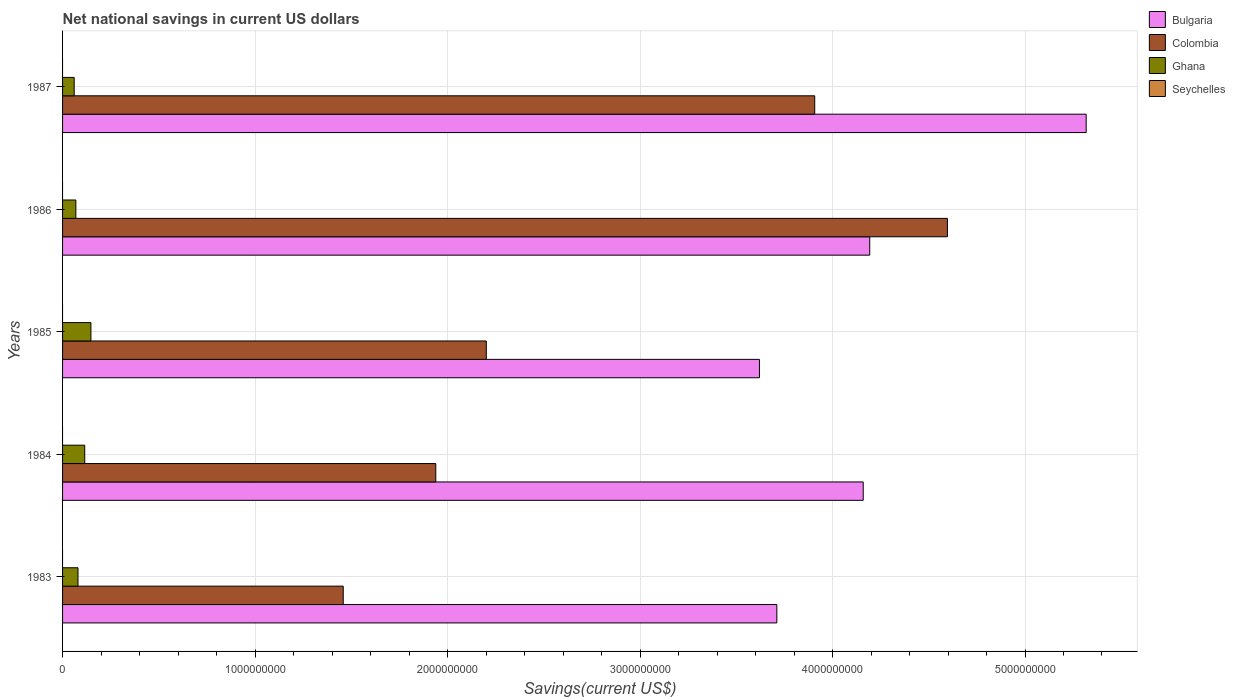How many different coloured bars are there?
Your answer should be compact. 3. How many groups of bars are there?
Offer a very short reply. 5. Are the number of bars per tick equal to the number of legend labels?
Your answer should be compact. No. Are the number of bars on each tick of the Y-axis equal?
Make the answer very short. Yes. Across all years, what is the maximum net national savings in Ghana?
Offer a very short reply. 1.47e+08. In which year was the net national savings in Colombia maximum?
Provide a short and direct response. 1986. What is the total net national savings in Bulgaria in the graph?
Offer a very short reply. 2.10e+1. What is the difference between the net national savings in Ghana in 1983 and that in 1984?
Your response must be concise. -3.50e+07. What is the difference between the net national savings in Ghana in 1987 and the net national savings in Seychelles in 1984?
Your response must be concise. 6.04e+07. What is the average net national savings in Colombia per year?
Offer a very short reply. 2.82e+09. In the year 1985, what is the difference between the net national savings in Bulgaria and net national savings in Colombia?
Make the answer very short. 1.42e+09. What is the ratio of the net national savings in Colombia in 1983 to that in 1987?
Offer a very short reply. 0.37. Is the net national savings in Bulgaria in 1983 less than that in 1984?
Offer a very short reply. Yes. What is the difference between the highest and the second highest net national savings in Ghana?
Keep it short and to the point. 3.21e+07. What is the difference between the highest and the lowest net national savings in Colombia?
Provide a short and direct response. 3.14e+09. Is the sum of the net national savings in Ghana in 1983 and 1985 greater than the maximum net national savings in Bulgaria across all years?
Ensure brevity in your answer.  No. Is it the case that in every year, the sum of the net national savings in Seychelles and net national savings in Colombia is greater than the sum of net national savings in Ghana and net national savings in Bulgaria?
Give a very brief answer. No. How many years are there in the graph?
Ensure brevity in your answer.  5. What is the difference between two consecutive major ticks on the X-axis?
Ensure brevity in your answer.  1.00e+09. Are the values on the major ticks of X-axis written in scientific E-notation?
Ensure brevity in your answer.  No. Does the graph contain grids?
Your answer should be compact. Yes. How many legend labels are there?
Keep it short and to the point. 4. What is the title of the graph?
Keep it short and to the point. Net national savings in current US dollars. What is the label or title of the X-axis?
Your response must be concise. Savings(current US$). What is the label or title of the Y-axis?
Your response must be concise. Years. What is the Savings(current US$) of Bulgaria in 1983?
Provide a succinct answer. 3.71e+09. What is the Savings(current US$) in Colombia in 1983?
Your response must be concise. 1.46e+09. What is the Savings(current US$) in Ghana in 1983?
Provide a succinct answer. 8.02e+07. What is the Savings(current US$) in Bulgaria in 1984?
Give a very brief answer. 4.16e+09. What is the Savings(current US$) of Colombia in 1984?
Your response must be concise. 1.94e+09. What is the Savings(current US$) of Ghana in 1984?
Your answer should be compact. 1.15e+08. What is the Savings(current US$) of Seychelles in 1984?
Ensure brevity in your answer.  0. What is the Savings(current US$) of Bulgaria in 1985?
Keep it short and to the point. 3.62e+09. What is the Savings(current US$) of Colombia in 1985?
Your response must be concise. 2.20e+09. What is the Savings(current US$) in Ghana in 1985?
Your answer should be compact. 1.47e+08. What is the Savings(current US$) of Bulgaria in 1986?
Make the answer very short. 4.19e+09. What is the Savings(current US$) of Colombia in 1986?
Provide a succinct answer. 4.60e+09. What is the Savings(current US$) in Ghana in 1986?
Give a very brief answer. 6.91e+07. What is the Savings(current US$) in Bulgaria in 1987?
Your answer should be compact. 5.32e+09. What is the Savings(current US$) in Colombia in 1987?
Offer a very short reply. 3.91e+09. What is the Savings(current US$) of Ghana in 1987?
Offer a terse response. 6.04e+07. Across all years, what is the maximum Savings(current US$) of Bulgaria?
Keep it short and to the point. 5.32e+09. Across all years, what is the maximum Savings(current US$) of Colombia?
Ensure brevity in your answer.  4.60e+09. Across all years, what is the maximum Savings(current US$) of Ghana?
Offer a very short reply. 1.47e+08. Across all years, what is the minimum Savings(current US$) of Bulgaria?
Provide a short and direct response. 3.62e+09. Across all years, what is the minimum Savings(current US$) of Colombia?
Offer a very short reply. 1.46e+09. Across all years, what is the minimum Savings(current US$) in Ghana?
Keep it short and to the point. 6.04e+07. What is the total Savings(current US$) in Bulgaria in the graph?
Your answer should be compact. 2.10e+1. What is the total Savings(current US$) of Colombia in the graph?
Ensure brevity in your answer.  1.41e+1. What is the total Savings(current US$) in Ghana in the graph?
Keep it short and to the point. 4.72e+08. What is the difference between the Savings(current US$) of Bulgaria in 1983 and that in 1984?
Your answer should be compact. -4.49e+08. What is the difference between the Savings(current US$) of Colombia in 1983 and that in 1984?
Your answer should be compact. -4.81e+08. What is the difference between the Savings(current US$) in Ghana in 1983 and that in 1984?
Your answer should be compact. -3.50e+07. What is the difference between the Savings(current US$) in Bulgaria in 1983 and that in 1985?
Ensure brevity in your answer.  9.03e+07. What is the difference between the Savings(current US$) in Colombia in 1983 and that in 1985?
Provide a succinct answer. -7.43e+08. What is the difference between the Savings(current US$) of Ghana in 1983 and that in 1985?
Provide a succinct answer. -6.72e+07. What is the difference between the Savings(current US$) of Bulgaria in 1983 and that in 1986?
Ensure brevity in your answer.  -4.83e+08. What is the difference between the Savings(current US$) in Colombia in 1983 and that in 1986?
Provide a short and direct response. -3.14e+09. What is the difference between the Savings(current US$) in Ghana in 1983 and that in 1986?
Offer a very short reply. 1.11e+07. What is the difference between the Savings(current US$) in Bulgaria in 1983 and that in 1987?
Offer a very short reply. -1.61e+09. What is the difference between the Savings(current US$) in Colombia in 1983 and that in 1987?
Ensure brevity in your answer.  -2.45e+09. What is the difference between the Savings(current US$) in Ghana in 1983 and that in 1987?
Your answer should be compact. 1.98e+07. What is the difference between the Savings(current US$) of Bulgaria in 1984 and that in 1985?
Offer a terse response. 5.39e+08. What is the difference between the Savings(current US$) of Colombia in 1984 and that in 1985?
Your response must be concise. -2.62e+08. What is the difference between the Savings(current US$) in Ghana in 1984 and that in 1985?
Make the answer very short. -3.21e+07. What is the difference between the Savings(current US$) of Bulgaria in 1984 and that in 1986?
Provide a short and direct response. -3.38e+07. What is the difference between the Savings(current US$) in Colombia in 1984 and that in 1986?
Your response must be concise. -2.66e+09. What is the difference between the Savings(current US$) in Ghana in 1984 and that in 1986?
Your answer should be compact. 4.61e+07. What is the difference between the Savings(current US$) in Bulgaria in 1984 and that in 1987?
Provide a succinct answer. -1.16e+09. What is the difference between the Savings(current US$) of Colombia in 1984 and that in 1987?
Your response must be concise. -1.97e+09. What is the difference between the Savings(current US$) of Ghana in 1984 and that in 1987?
Make the answer very short. 5.48e+07. What is the difference between the Savings(current US$) of Bulgaria in 1985 and that in 1986?
Give a very brief answer. -5.73e+08. What is the difference between the Savings(current US$) in Colombia in 1985 and that in 1986?
Give a very brief answer. -2.40e+09. What is the difference between the Savings(current US$) of Ghana in 1985 and that in 1986?
Your answer should be compact. 7.83e+07. What is the difference between the Savings(current US$) in Bulgaria in 1985 and that in 1987?
Make the answer very short. -1.70e+09. What is the difference between the Savings(current US$) of Colombia in 1985 and that in 1987?
Keep it short and to the point. -1.71e+09. What is the difference between the Savings(current US$) in Ghana in 1985 and that in 1987?
Provide a short and direct response. 8.69e+07. What is the difference between the Savings(current US$) of Bulgaria in 1986 and that in 1987?
Give a very brief answer. -1.12e+09. What is the difference between the Savings(current US$) in Colombia in 1986 and that in 1987?
Make the answer very short. 6.89e+08. What is the difference between the Savings(current US$) in Ghana in 1986 and that in 1987?
Offer a very short reply. 8.68e+06. What is the difference between the Savings(current US$) in Bulgaria in 1983 and the Savings(current US$) in Colombia in 1984?
Make the answer very short. 1.77e+09. What is the difference between the Savings(current US$) in Bulgaria in 1983 and the Savings(current US$) in Ghana in 1984?
Offer a very short reply. 3.60e+09. What is the difference between the Savings(current US$) in Colombia in 1983 and the Savings(current US$) in Ghana in 1984?
Provide a succinct answer. 1.34e+09. What is the difference between the Savings(current US$) in Bulgaria in 1983 and the Savings(current US$) in Colombia in 1985?
Offer a very short reply. 1.51e+09. What is the difference between the Savings(current US$) in Bulgaria in 1983 and the Savings(current US$) in Ghana in 1985?
Give a very brief answer. 3.56e+09. What is the difference between the Savings(current US$) in Colombia in 1983 and the Savings(current US$) in Ghana in 1985?
Provide a short and direct response. 1.31e+09. What is the difference between the Savings(current US$) of Bulgaria in 1983 and the Savings(current US$) of Colombia in 1986?
Ensure brevity in your answer.  -8.86e+08. What is the difference between the Savings(current US$) of Bulgaria in 1983 and the Savings(current US$) of Ghana in 1986?
Your response must be concise. 3.64e+09. What is the difference between the Savings(current US$) of Colombia in 1983 and the Savings(current US$) of Ghana in 1986?
Your answer should be very brief. 1.39e+09. What is the difference between the Savings(current US$) in Bulgaria in 1983 and the Savings(current US$) in Colombia in 1987?
Make the answer very short. -1.97e+08. What is the difference between the Savings(current US$) of Bulgaria in 1983 and the Savings(current US$) of Ghana in 1987?
Ensure brevity in your answer.  3.65e+09. What is the difference between the Savings(current US$) of Colombia in 1983 and the Savings(current US$) of Ghana in 1987?
Ensure brevity in your answer.  1.40e+09. What is the difference between the Savings(current US$) of Bulgaria in 1984 and the Savings(current US$) of Colombia in 1985?
Ensure brevity in your answer.  1.96e+09. What is the difference between the Savings(current US$) in Bulgaria in 1984 and the Savings(current US$) in Ghana in 1985?
Keep it short and to the point. 4.01e+09. What is the difference between the Savings(current US$) in Colombia in 1984 and the Savings(current US$) in Ghana in 1985?
Your response must be concise. 1.79e+09. What is the difference between the Savings(current US$) in Bulgaria in 1984 and the Savings(current US$) in Colombia in 1986?
Your response must be concise. -4.37e+08. What is the difference between the Savings(current US$) of Bulgaria in 1984 and the Savings(current US$) of Ghana in 1986?
Make the answer very short. 4.09e+09. What is the difference between the Savings(current US$) in Colombia in 1984 and the Savings(current US$) in Ghana in 1986?
Keep it short and to the point. 1.87e+09. What is the difference between the Savings(current US$) of Bulgaria in 1984 and the Savings(current US$) of Colombia in 1987?
Your answer should be compact. 2.52e+08. What is the difference between the Savings(current US$) of Bulgaria in 1984 and the Savings(current US$) of Ghana in 1987?
Offer a terse response. 4.10e+09. What is the difference between the Savings(current US$) in Colombia in 1984 and the Savings(current US$) in Ghana in 1987?
Provide a succinct answer. 1.88e+09. What is the difference between the Savings(current US$) in Bulgaria in 1985 and the Savings(current US$) in Colombia in 1986?
Keep it short and to the point. -9.76e+08. What is the difference between the Savings(current US$) of Bulgaria in 1985 and the Savings(current US$) of Ghana in 1986?
Ensure brevity in your answer.  3.55e+09. What is the difference between the Savings(current US$) of Colombia in 1985 and the Savings(current US$) of Ghana in 1986?
Keep it short and to the point. 2.13e+09. What is the difference between the Savings(current US$) in Bulgaria in 1985 and the Savings(current US$) in Colombia in 1987?
Offer a very short reply. -2.87e+08. What is the difference between the Savings(current US$) in Bulgaria in 1985 and the Savings(current US$) in Ghana in 1987?
Offer a very short reply. 3.56e+09. What is the difference between the Savings(current US$) of Colombia in 1985 and the Savings(current US$) of Ghana in 1987?
Provide a short and direct response. 2.14e+09. What is the difference between the Savings(current US$) in Bulgaria in 1986 and the Savings(current US$) in Colombia in 1987?
Offer a terse response. 2.86e+08. What is the difference between the Savings(current US$) in Bulgaria in 1986 and the Savings(current US$) in Ghana in 1987?
Your response must be concise. 4.13e+09. What is the difference between the Savings(current US$) of Colombia in 1986 and the Savings(current US$) of Ghana in 1987?
Offer a very short reply. 4.54e+09. What is the average Savings(current US$) of Bulgaria per year?
Give a very brief answer. 4.20e+09. What is the average Savings(current US$) in Colombia per year?
Your answer should be very brief. 2.82e+09. What is the average Savings(current US$) of Ghana per year?
Make the answer very short. 9.44e+07. In the year 1983, what is the difference between the Savings(current US$) in Bulgaria and Savings(current US$) in Colombia?
Make the answer very short. 2.25e+09. In the year 1983, what is the difference between the Savings(current US$) in Bulgaria and Savings(current US$) in Ghana?
Your answer should be compact. 3.63e+09. In the year 1983, what is the difference between the Savings(current US$) in Colombia and Savings(current US$) in Ghana?
Your answer should be very brief. 1.38e+09. In the year 1984, what is the difference between the Savings(current US$) in Bulgaria and Savings(current US$) in Colombia?
Offer a terse response. 2.22e+09. In the year 1984, what is the difference between the Savings(current US$) in Bulgaria and Savings(current US$) in Ghana?
Offer a terse response. 4.04e+09. In the year 1984, what is the difference between the Savings(current US$) of Colombia and Savings(current US$) of Ghana?
Ensure brevity in your answer.  1.82e+09. In the year 1985, what is the difference between the Savings(current US$) in Bulgaria and Savings(current US$) in Colombia?
Your answer should be very brief. 1.42e+09. In the year 1985, what is the difference between the Savings(current US$) in Bulgaria and Savings(current US$) in Ghana?
Keep it short and to the point. 3.47e+09. In the year 1985, what is the difference between the Savings(current US$) in Colombia and Savings(current US$) in Ghana?
Provide a short and direct response. 2.05e+09. In the year 1986, what is the difference between the Savings(current US$) of Bulgaria and Savings(current US$) of Colombia?
Provide a short and direct response. -4.04e+08. In the year 1986, what is the difference between the Savings(current US$) in Bulgaria and Savings(current US$) in Ghana?
Your response must be concise. 4.12e+09. In the year 1986, what is the difference between the Savings(current US$) in Colombia and Savings(current US$) in Ghana?
Provide a succinct answer. 4.53e+09. In the year 1987, what is the difference between the Savings(current US$) of Bulgaria and Savings(current US$) of Colombia?
Offer a terse response. 1.41e+09. In the year 1987, what is the difference between the Savings(current US$) in Bulgaria and Savings(current US$) in Ghana?
Offer a very short reply. 5.26e+09. In the year 1987, what is the difference between the Savings(current US$) in Colombia and Savings(current US$) in Ghana?
Make the answer very short. 3.85e+09. What is the ratio of the Savings(current US$) in Bulgaria in 1983 to that in 1984?
Offer a terse response. 0.89. What is the ratio of the Savings(current US$) of Colombia in 1983 to that in 1984?
Your answer should be compact. 0.75. What is the ratio of the Savings(current US$) of Ghana in 1983 to that in 1984?
Keep it short and to the point. 0.7. What is the ratio of the Savings(current US$) in Bulgaria in 1983 to that in 1985?
Your answer should be very brief. 1.02. What is the ratio of the Savings(current US$) in Colombia in 1983 to that in 1985?
Offer a very short reply. 0.66. What is the ratio of the Savings(current US$) in Ghana in 1983 to that in 1985?
Offer a terse response. 0.54. What is the ratio of the Savings(current US$) in Bulgaria in 1983 to that in 1986?
Offer a very short reply. 0.88. What is the ratio of the Savings(current US$) of Colombia in 1983 to that in 1986?
Your answer should be compact. 0.32. What is the ratio of the Savings(current US$) of Ghana in 1983 to that in 1986?
Give a very brief answer. 1.16. What is the ratio of the Savings(current US$) of Bulgaria in 1983 to that in 1987?
Make the answer very short. 0.7. What is the ratio of the Savings(current US$) of Colombia in 1983 to that in 1987?
Offer a terse response. 0.37. What is the ratio of the Savings(current US$) of Ghana in 1983 to that in 1987?
Provide a succinct answer. 1.33. What is the ratio of the Savings(current US$) of Bulgaria in 1984 to that in 1985?
Offer a terse response. 1.15. What is the ratio of the Savings(current US$) in Colombia in 1984 to that in 1985?
Keep it short and to the point. 0.88. What is the ratio of the Savings(current US$) of Ghana in 1984 to that in 1985?
Your answer should be very brief. 0.78. What is the ratio of the Savings(current US$) in Colombia in 1984 to that in 1986?
Make the answer very short. 0.42. What is the ratio of the Savings(current US$) of Ghana in 1984 to that in 1986?
Your answer should be very brief. 1.67. What is the ratio of the Savings(current US$) of Bulgaria in 1984 to that in 1987?
Offer a terse response. 0.78. What is the ratio of the Savings(current US$) of Colombia in 1984 to that in 1987?
Make the answer very short. 0.5. What is the ratio of the Savings(current US$) in Ghana in 1984 to that in 1987?
Ensure brevity in your answer.  1.91. What is the ratio of the Savings(current US$) in Bulgaria in 1985 to that in 1986?
Your response must be concise. 0.86. What is the ratio of the Savings(current US$) in Colombia in 1985 to that in 1986?
Offer a terse response. 0.48. What is the ratio of the Savings(current US$) in Ghana in 1985 to that in 1986?
Offer a terse response. 2.13. What is the ratio of the Savings(current US$) of Bulgaria in 1985 to that in 1987?
Your response must be concise. 0.68. What is the ratio of the Savings(current US$) in Colombia in 1985 to that in 1987?
Keep it short and to the point. 0.56. What is the ratio of the Savings(current US$) of Ghana in 1985 to that in 1987?
Offer a very short reply. 2.44. What is the ratio of the Savings(current US$) in Bulgaria in 1986 to that in 1987?
Your answer should be compact. 0.79. What is the ratio of the Savings(current US$) of Colombia in 1986 to that in 1987?
Offer a terse response. 1.18. What is the ratio of the Savings(current US$) of Ghana in 1986 to that in 1987?
Offer a terse response. 1.14. What is the difference between the highest and the second highest Savings(current US$) in Bulgaria?
Offer a terse response. 1.12e+09. What is the difference between the highest and the second highest Savings(current US$) in Colombia?
Provide a succinct answer. 6.89e+08. What is the difference between the highest and the second highest Savings(current US$) of Ghana?
Keep it short and to the point. 3.21e+07. What is the difference between the highest and the lowest Savings(current US$) of Bulgaria?
Provide a short and direct response. 1.70e+09. What is the difference between the highest and the lowest Savings(current US$) in Colombia?
Keep it short and to the point. 3.14e+09. What is the difference between the highest and the lowest Savings(current US$) of Ghana?
Make the answer very short. 8.69e+07. 